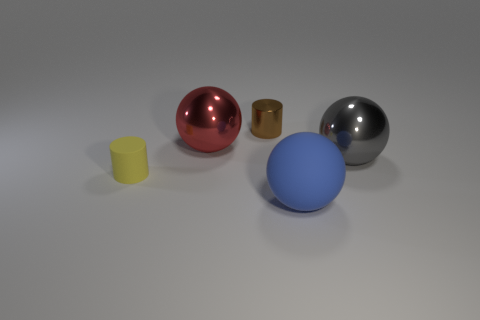Subtract all blue rubber spheres. How many spheres are left? 2 Subtract 1 spheres. How many spheres are left? 2 Subtract all green balls. Subtract all brown cylinders. How many balls are left? 3 Add 4 large gray blocks. How many objects exist? 9 Subtract all cylinders. How many objects are left? 3 Add 4 large blue things. How many large blue things are left? 5 Add 2 big purple matte cylinders. How many big purple matte cylinders exist? 2 Subtract 0 cyan cylinders. How many objects are left? 5 Subtract all tiny gray matte cylinders. Subtract all large metal balls. How many objects are left? 3 